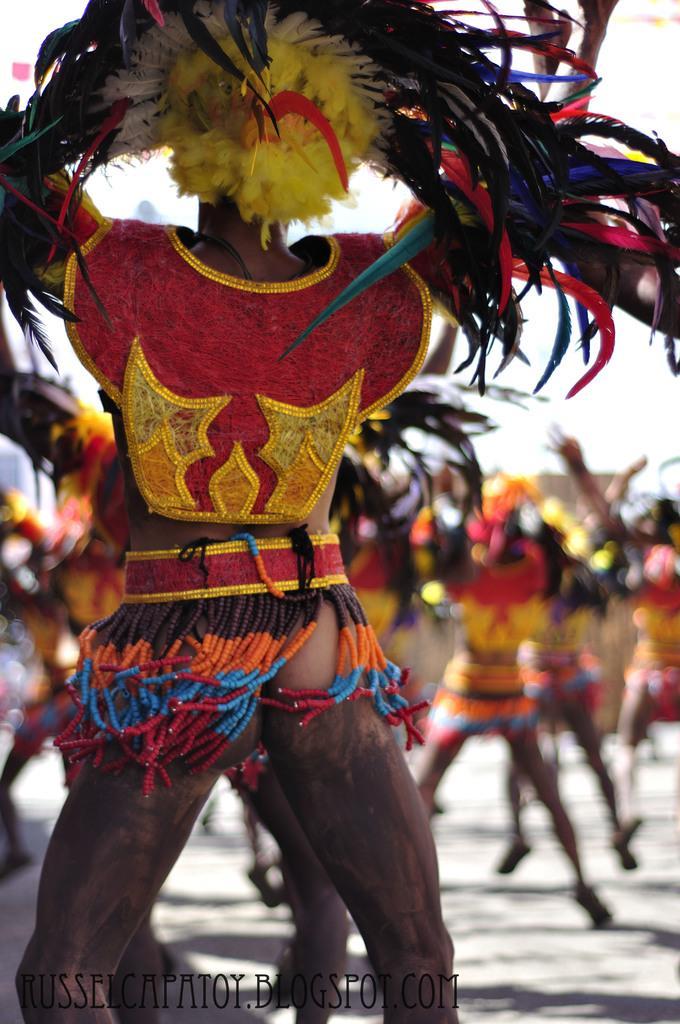Could you give a brief overview of what you see in this image? In this image we can see some persons who wore traditional dress for carnival fest. 